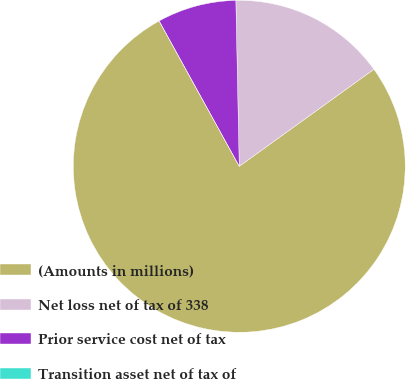Convert chart to OTSL. <chart><loc_0><loc_0><loc_500><loc_500><pie_chart><fcel>(Amounts in millions)<fcel>Net loss net of tax of 338<fcel>Prior service cost net of tax<fcel>Transition asset net of tax of<nl><fcel>76.92%<fcel>15.39%<fcel>7.69%<fcel>0.0%<nl></chart> 